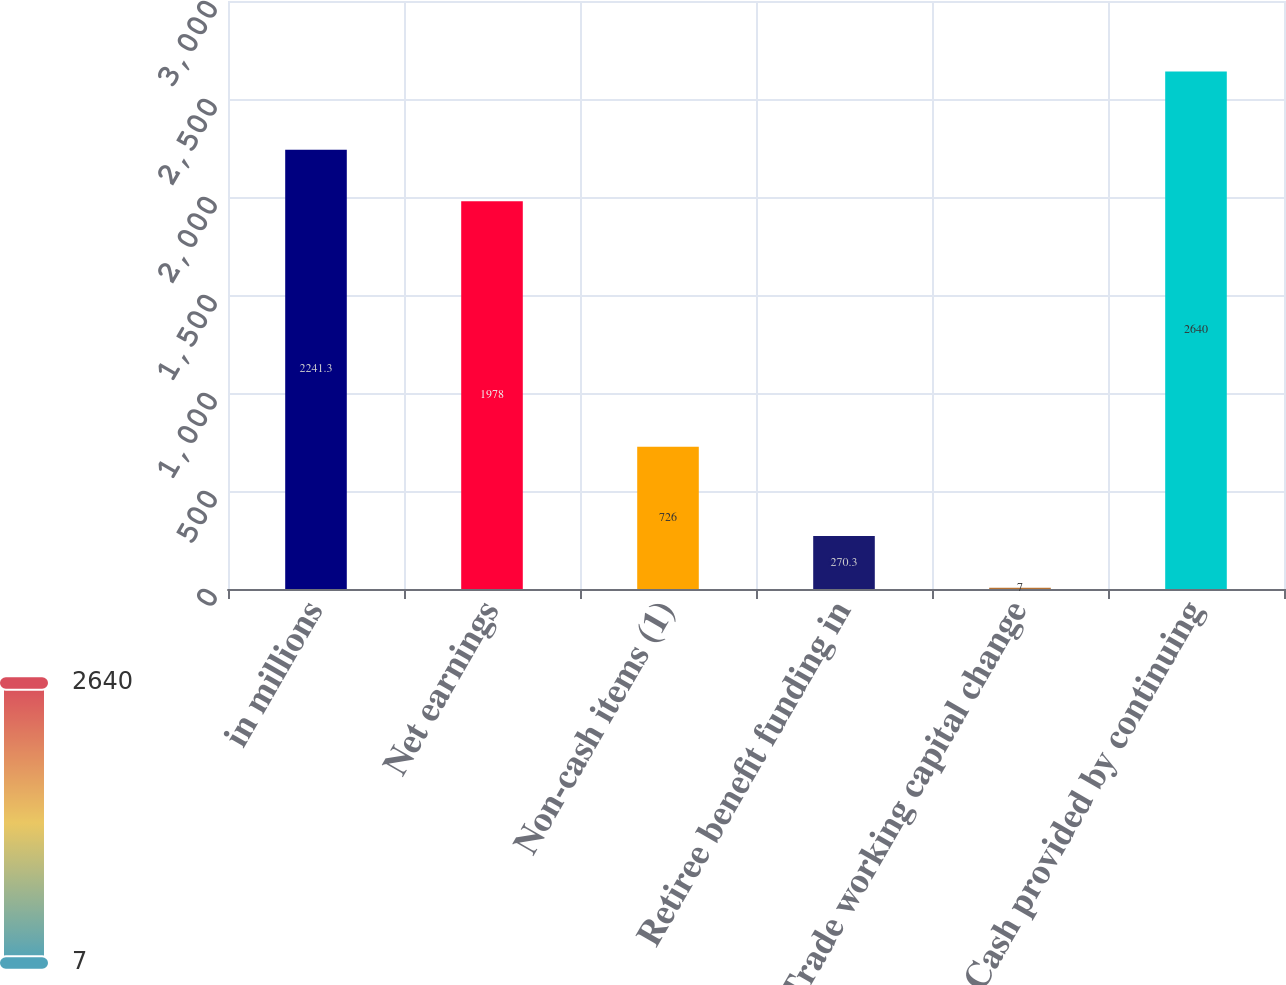Convert chart to OTSL. <chart><loc_0><loc_0><loc_500><loc_500><bar_chart><fcel>in millions<fcel>Net earnings<fcel>Non-cash items (1)<fcel>Retiree benefit funding in<fcel>Trade working capital change<fcel>Cash provided by continuing<nl><fcel>2241.3<fcel>1978<fcel>726<fcel>270.3<fcel>7<fcel>2640<nl></chart> 